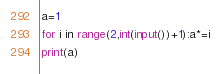<code> <loc_0><loc_0><loc_500><loc_500><_Python_>a=1
for i in range(2,int(input())+1):a*=i
print(a)
</code> 